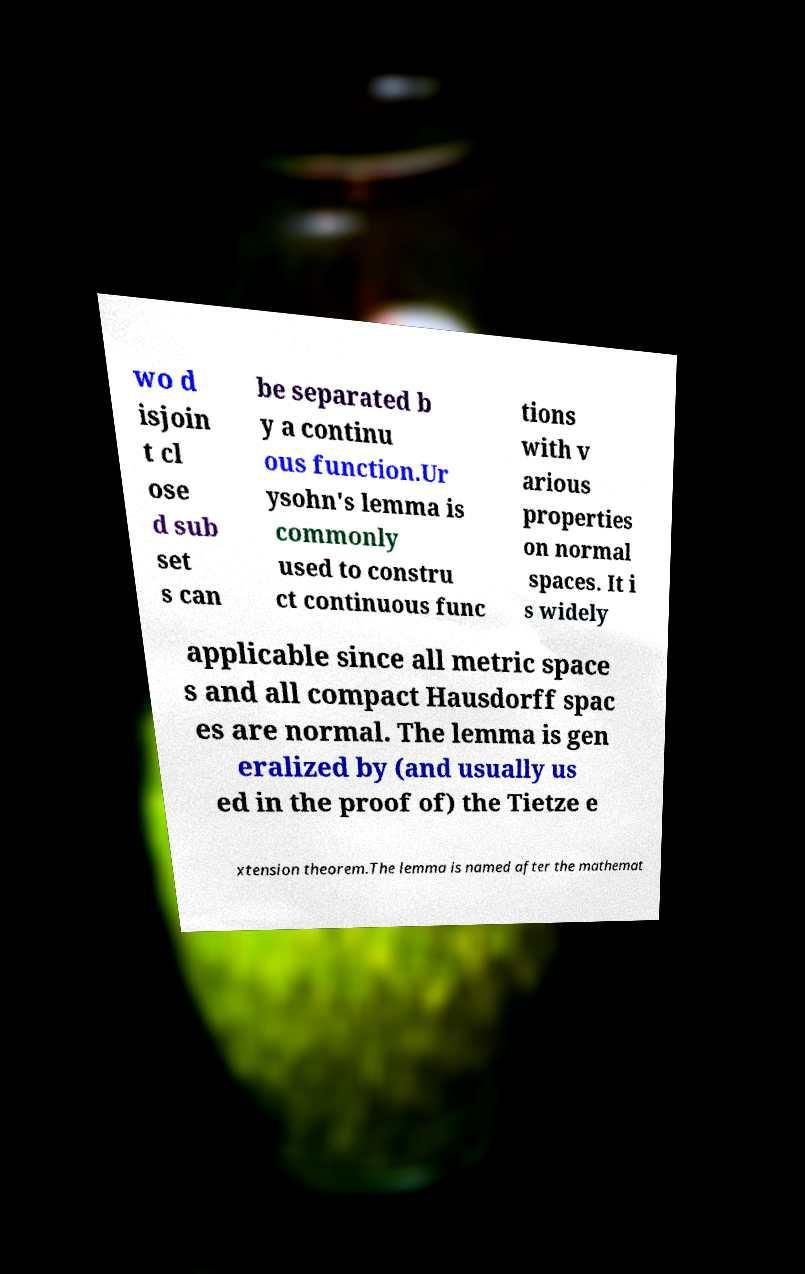Please identify and transcribe the text found in this image. wo d isjoin t cl ose d sub set s can be separated b y a continu ous function.Ur ysohn's lemma is commonly used to constru ct continuous func tions with v arious properties on normal spaces. It i s widely applicable since all metric space s and all compact Hausdorff spac es are normal. The lemma is gen eralized by (and usually us ed in the proof of) the Tietze e xtension theorem.The lemma is named after the mathemat 